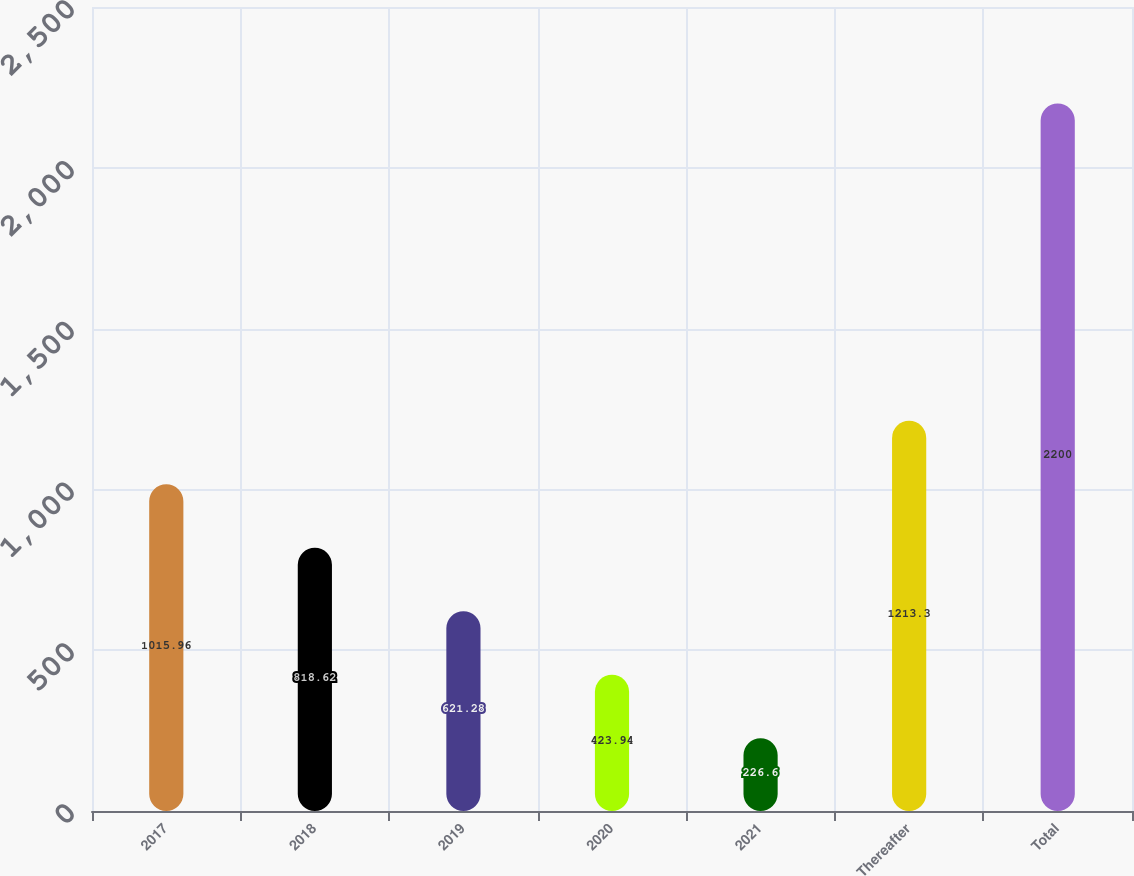<chart> <loc_0><loc_0><loc_500><loc_500><bar_chart><fcel>2017<fcel>2018<fcel>2019<fcel>2020<fcel>2021<fcel>Thereafter<fcel>Total<nl><fcel>1015.96<fcel>818.62<fcel>621.28<fcel>423.94<fcel>226.6<fcel>1213.3<fcel>2200<nl></chart> 